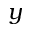Convert formula to latex. <formula><loc_0><loc_0><loc_500><loc_500>y</formula> 